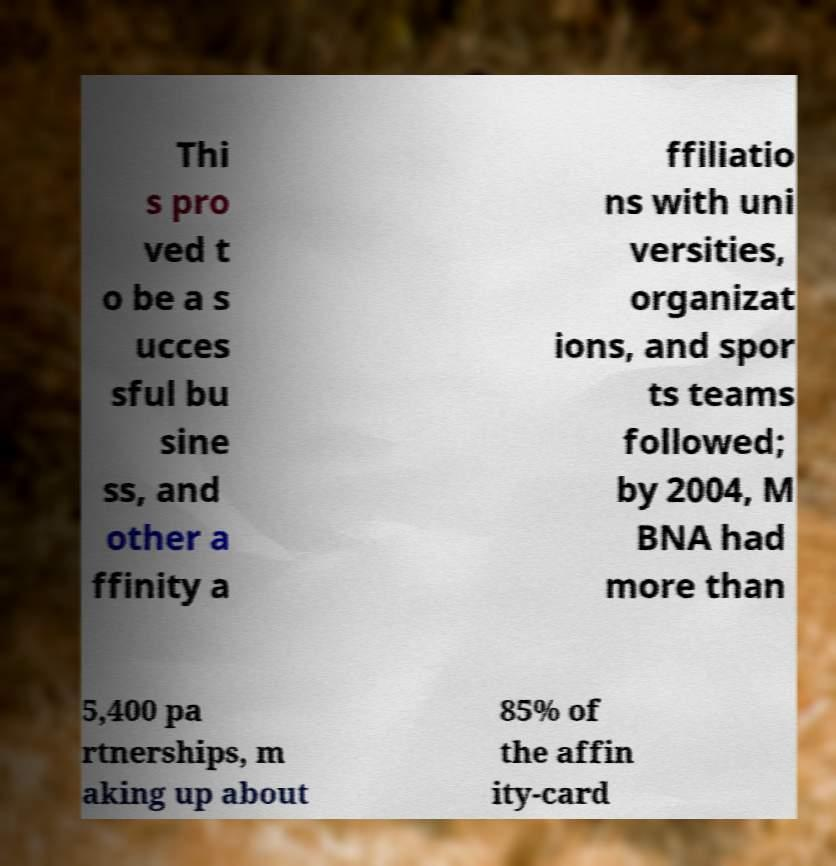Can you accurately transcribe the text from the provided image for me? Thi s pro ved t o be a s ucces sful bu sine ss, and other a ffinity a ffiliatio ns with uni versities, organizat ions, and spor ts teams followed; by 2004, M BNA had more than 5,400 pa rtnerships, m aking up about 85% of the affin ity-card 